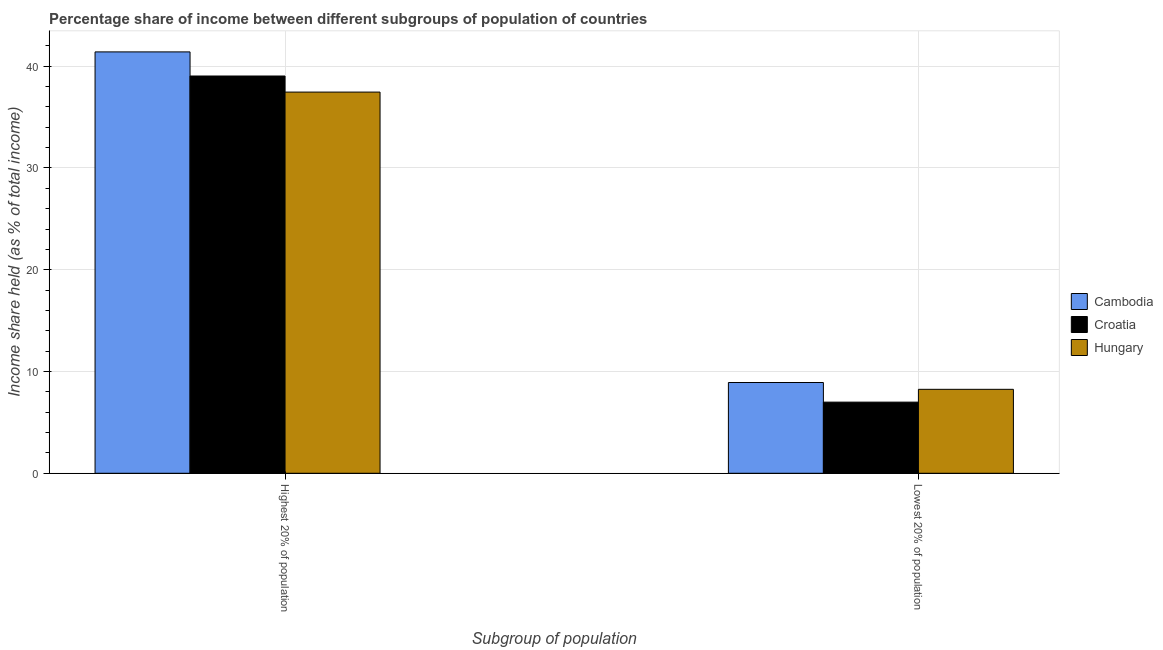How many different coloured bars are there?
Provide a short and direct response. 3. Are the number of bars on each tick of the X-axis equal?
Offer a terse response. Yes. How many bars are there on the 2nd tick from the left?
Offer a terse response. 3. How many bars are there on the 1st tick from the right?
Your answer should be compact. 3. What is the label of the 1st group of bars from the left?
Your response must be concise. Highest 20% of population. What is the income share held by highest 20% of the population in Cambodia?
Your response must be concise. 41.41. Across all countries, what is the maximum income share held by highest 20% of the population?
Provide a short and direct response. 41.41. Across all countries, what is the minimum income share held by lowest 20% of the population?
Give a very brief answer. 6.99. In which country was the income share held by highest 20% of the population maximum?
Your response must be concise. Cambodia. In which country was the income share held by lowest 20% of the population minimum?
Offer a terse response. Croatia. What is the total income share held by lowest 20% of the population in the graph?
Your answer should be compact. 24.16. What is the difference between the income share held by lowest 20% of the population in Hungary and that in Cambodia?
Keep it short and to the point. -0.67. What is the difference between the income share held by lowest 20% of the population in Croatia and the income share held by highest 20% of the population in Hungary?
Offer a terse response. -30.47. What is the average income share held by highest 20% of the population per country?
Offer a very short reply. 39.3. What is the difference between the income share held by highest 20% of the population and income share held by lowest 20% of the population in Cambodia?
Ensure brevity in your answer.  32.49. What is the ratio of the income share held by highest 20% of the population in Hungary to that in Croatia?
Ensure brevity in your answer.  0.96. In how many countries, is the income share held by highest 20% of the population greater than the average income share held by highest 20% of the population taken over all countries?
Make the answer very short. 1. What does the 1st bar from the left in Highest 20% of population represents?
Keep it short and to the point. Cambodia. What does the 1st bar from the right in Highest 20% of population represents?
Offer a very short reply. Hungary. Are all the bars in the graph horizontal?
Offer a terse response. No. What is the difference between two consecutive major ticks on the Y-axis?
Make the answer very short. 10. Where does the legend appear in the graph?
Your answer should be compact. Center right. How many legend labels are there?
Offer a very short reply. 3. How are the legend labels stacked?
Your answer should be compact. Vertical. What is the title of the graph?
Offer a very short reply. Percentage share of income between different subgroups of population of countries. Does "Hong Kong" appear as one of the legend labels in the graph?
Offer a very short reply. No. What is the label or title of the X-axis?
Your answer should be very brief. Subgroup of population. What is the label or title of the Y-axis?
Ensure brevity in your answer.  Income share held (as % of total income). What is the Income share held (as % of total income) of Cambodia in Highest 20% of population?
Your response must be concise. 41.41. What is the Income share held (as % of total income) in Croatia in Highest 20% of population?
Ensure brevity in your answer.  39.04. What is the Income share held (as % of total income) in Hungary in Highest 20% of population?
Keep it short and to the point. 37.46. What is the Income share held (as % of total income) in Cambodia in Lowest 20% of population?
Give a very brief answer. 8.92. What is the Income share held (as % of total income) of Croatia in Lowest 20% of population?
Offer a terse response. 6.99. What is the Income share held (as % of total income) in Hungary in Lowest 20% of population?
Your answer should be very brief. 8.25. Across all Subgroup of population, what is the maximum Income share held (as % of total income) of Cambodia?
Give a very brief answer. 41.41. Across all Subgroup of population, what is the maximum Income share held (as % of total income) in Croatia?
Provide a short and direct response. 39.04. Across all Subgroup of population, what is the maximum Income share held (as % of total income) of Hungary?
Give a very brief answer. 37.46. Across all Subgroup of population, what is the minimum Income share held (as % of total income) of Cambodia?
Keep it short and to the point. 8.92. Across all Subgroup of population, what is the minimum Income share held (as % of total income) in Croatia?
Your answer should be compact. 6.99. Across all Subgroup of population, what is the minimum Income share held (as % of total income) of Hungary?
Offer a very short reply. 8.25. What is the total Income share held (as % of total income) in Cambodia in the graph?
Offer a terse response. 50.33. What is the total Income share held (as % of total income) in Croatia in the graph?
Make the answer very short. 46.03. What is the total Income share held (as % of total income) in Hungary in the graph?
Provide a short and direct response. 45.71. What is the difference between the Income share held (as % of total income) of Cambodia in Highest 20% of population and that in Lowest 20% of population?
Give a very brief answer. 32.49. What is the difference between the Income share held (as % of total income) of Croatia in Highest 20% of population and that in Lowest 20% of population?
Provide a short and direct response. 32.05. What is the difference between the Income share held (as % of total income) of Hungary in Highest 20% of population and that in Lowest 20% of population?
Provide a short and direct response. 29.21. What is the difference between the Income share held (as % of total income) of Cambodia in Highest 20% of population and the Income share held (as % of total income) of Croatia in Lowest 20% of population?
Give a very brief answer. 34.42. What is the difference between the Income share held (as % of total income) in Cambodia in Highest 20% of population and the Income share held (as % of total income) in Hungary in Lowest 20% of population?
Make the answer very short. 33.16. What is the difference between the Income share held (as % of total income) of Croatia in Highest 20% of population and the Income share held (as % of total income) of Hungary in Lowest 20% of population?
Your response must be concise. 30.79. What is the average Income share held (as % of total income) in Cambodia per Subgroup of population?
Your response must be concise. 25.16. What is the average Income share held (as % of total income) of Croatia per Subgroup of population?
Offer a very short reply. 23.02. What is the average Income share held (as % of total income) of Hungary per Subgroup of population?
Give a very brief answer. 22.86. What is the difference between the Income share held (as % of total income) of Cambodia and Income share held (as % of total income) of Croatia in Highest 20% of population?
Offer a very short reply. 2.37. What is the difference between the Income share held (as % of total income) in Cambodia and Income share held (as % of total income) in Hungary in Highest 20% of population?
Offer a terse response. 3.95. What is the difference between the Income share held (as % of total income) in Croatia and Income share held (as % of total income) in Hungary in Highest 20% of population?
Give a very brief answer. 1.58. What is the difference between the Income share held (as % of total income) of Cambodia and Income share held (as % of total income) of Croatia in Lowest 20% of population?
Offer a very short reply. 1.93. What is the difference between the Income share held (as % of total income) of Cambodia and Income share held (as % of total income) of Hungary in Lowest 20% of population?
Offer a very short reply. 0.67. What is the difference between the Income share held (as % of total income) of Croatia and Income share held (as % of total income) of Hungary in Lowest 20% of population?
Keep it short and to the point. -1.26. What is the ratio of the Income share held (as % of total income) of Cambodia in Highest 20% of population to that in Lowest 20% of population?
Ensure brevity in your answer.  4.64. What is the ratio of the Income share held (as % of total income) of Croatia in Highest 20% of population to that in Lowest 20% of population?
Provide a short and direct response. 5.59. What is the ratio of the Income share held (as % of total income) in Hungary in Highest 20% of population to that in Lowest 20% of population?
Make the answer very short. 4.54. What is the difference between the highest and the second highest Income share held (as % of total income) of Cambodia?
Give a very brief answer. 32.49. What is the difference between the highest and the second highest Income share held (as % of total income) in Croatia?
Provide a succinct answer. 32.05. What is the difference between the highest and the second highest Income share held (as % of total income) in Hungary?
Keep it short and to the point. 29.21. What is the difference between the highest and the lowest Income share held (as % of total income) in Cambodia?
Your response must be concise. 32.49. What is the difference between the highest and the lowest Income share held (as % of total income) in Croatia?
Your answer should be very brief. 32.05. What is the difference between the highest and the lowest Income share held (as % of total income) in Hungary?
Make the answer very short. 29.21. 